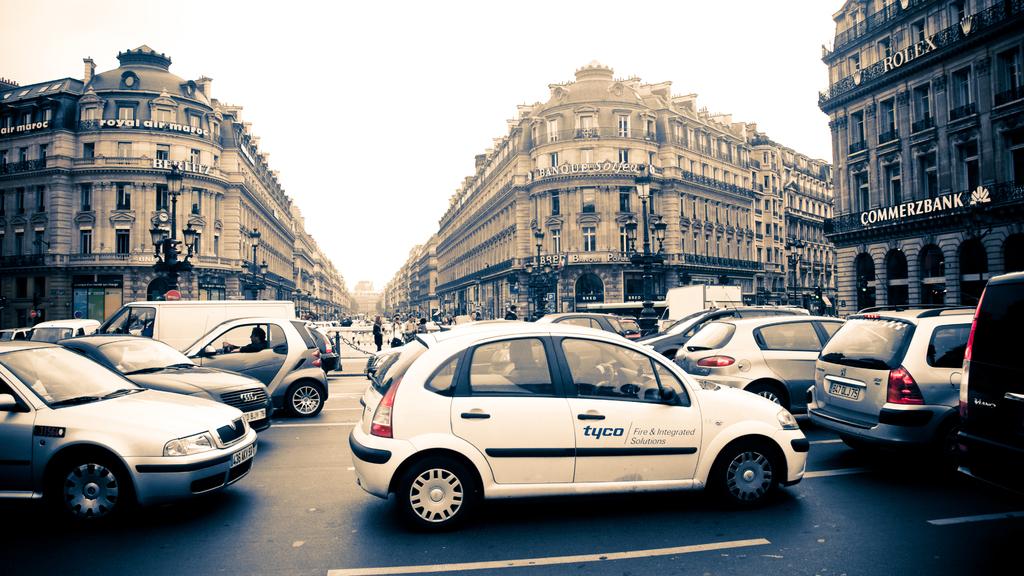What watch company is advertised on the building?
Your answer should be very brief. Rolex. What word is on the side of the car?
Provide a succinct answer. Tyco. 